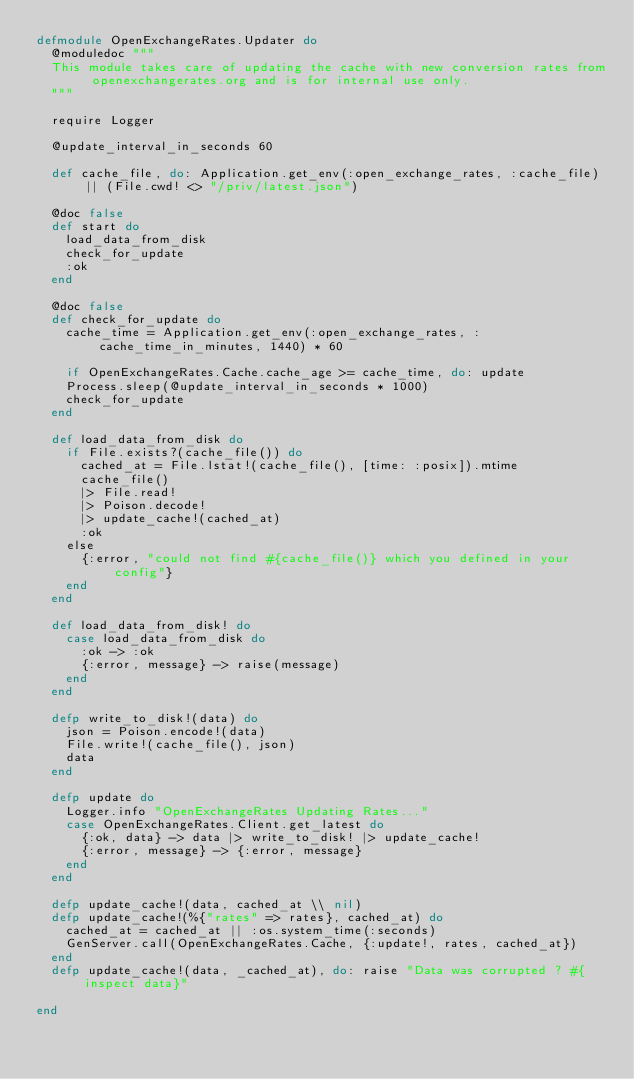Convert code to text. <code><loc_0><loc_0><loc_500><loc_500><_Elixir_>defmodule OpenExchangeRates.Updater do
  @moduledoc """
  This module takes care of updating the cache with new conversion rates from openexchangerates.org and is for internal use only.
  """

  require Logger

  @update_interval_in_seconds 60

  def cache_file, do: Application.get_env(:open_exchange_rates, :cache_file) || (File.cwd! <> "/priv/latest.json")

  @doc false
  def start do
    load_data_from_disk
    check_for_update
    :ok
  end

  @doc false
  def check_for_update do
    cache_time = Application.get_env(:open_exchange_rates, :cache_time_in_minutes, 1440) * 60

    if OpenExchangeRates.Cache.cache_age >= cache_time, do: update
    Process.sleep(@update_interval_in_seconds * 1000)
    check_for_update
  end

  def load_data_from_disk do
    if File.exists?(cache_file()) do
      cached_at = File.lstat!(cache_file(), [time: :posix]).mtime
      cache_file()
      |> File.read!
      |> Poison.decode!
      |> update_cache!(cached_at)
      :ok
    else
      {:error, "could not find #{cache_file()} which you defined in your config"}
    end
  end

  def load_data_from_disk! do
    case load_data_from_disk do
      :ok -> :ok
      {:error, message} -> raise(message)
    end
  end

  defp write_to_disk!(data) do
    json = Poison.encode!(data)
    File.write!(cache_file(), json)
    data
  end

  defp update do
    Logger.info "OpenExchangeRates Updating Rates..."
    case OpenExchangeRates.Client.get_latest do
      {:ok, data} -> data |> write_to_disk! |> update_cache!
      {:error, message} -> {:error, message}
    end
  end

  defp update_cache!(data, cached_at \\ nil)
  defp update_cache!(%{"rates" => rates}, cached_at) do
    cached_at = cached_at || :os.system_time(:seconds)
    GenServer.call(OpenExchangeRates.Cache, {:update!, rates, cached_at})
  end
  defp update_cache!(data, _cached_at), do: raise "Data was corrupted ? #{inspect data}"

end
</code> 